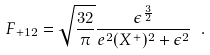Convert formula to latex. <formula><loc_0><loc_0><loc_500><loc_500>F _ { + 1 2 } = \sqrt { \frac { 3 2 } { \pi } } \frac { \epsilon ^ { \frac { 3 } { 2 } } } { e ^ { 2 } ( X ^ { + } ) ^ { 2 } + \epsilon ^ { 2 } } \ .</formula> 